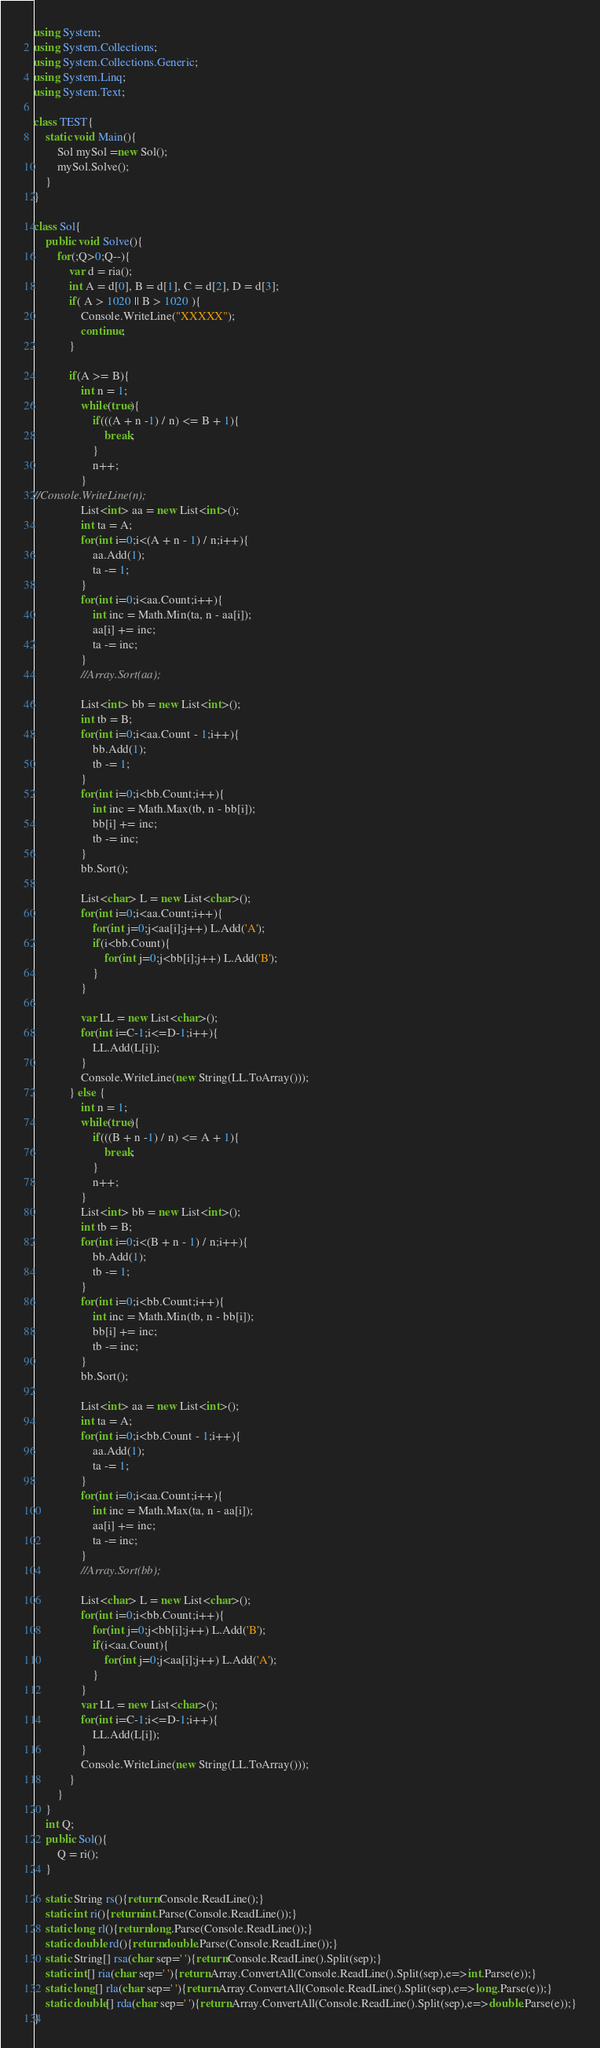<code> <loc_0><loc_0><loc_500><loc_500><_C#_>using System;
using System.Collections;
using System.Collections.Generic;
using System.Linq;
using System.Text;

class TEST{
	static void Main(){
		Sol mySol =new Sol();
		mySol.Solve();
	}
}

class Sol{
	public void Solve(){
		for(;Q>0;Q--){
			var d = ria();
			int A = d[0], B = d[1], C = d[2], D = d[3];
			if( A > 1020 || B > 1020 ){
				Console.WriteLine("XXXXX");
				continue;
			}
			
			if(A >= B){
				int n = 1;
				while(true){
					if(((A + n -1) / n) <= B + 1){
						break;
					}
					n++;
				}
//Console.WriteLine(n);				
				List<int> aa = new List<int>();
				int ta = A;
				for(int i=0;i<(A + n - 1) / n;i++){
					aa.Add(1);
					ta -= 1;
				}
				for(int i=0;i<aa.Count;i++){
					int inc = Math.Min(ta, n - aa[i]);
					aa[i] += inc;
					ta -= inc;
				}
				//Array.Sort(aa);
				
				List<int> bb = new List<int>();
				int tb = B;
				for(int i=0;i<aa.Count - 1;i++){
					bb.Add(1);
					tb -= 1;
				}
				for(int i=0;i<bb.Count;i++){
					int inc = Math.Max(tb, n - bb[i]);
					bb[i] += inc;
					tb -= inc;
				}
				bb.Sort();
				
				List<char> L = new List<char>();
				for(int i=0;i<aa.Count;i++){
					for(int j=0;j<aa[i];j++) L.Add('A');
					if(i<bb.Count){
						for(int j=0;j<bb[i];j++) L.Add('B');
					}
				}
				
				var LL = new List<char>();
				for(int i=C-1;i<=D-1;i++){
					LL.Add(L[i]);
				}
				Console.WriteLine(new String(LL.ToArray()));
			} else {
				int n = 1;
				while(true){
					if(((B + n -1) / n) <= A + 1){
						break;
					}
					n++;
				}
				List<int> bb = new List<int>();
				int tb = B;
				for(int i=0;i<(B + n - 1) / n;i++){
					bb.Add(1);
					tb -= 1;
				}
				for(int i=0;i<bb.Count;i++){
					int inc = Math.Min(tb, n - bb[i]);
					bb[i] += inc;
					tb -= inc;
				}
				bb.Sort();
				
				List<int> aa = new List<int>();
				int ta = A;
				for(int i=0;i<bb.Count - 1;i++){
					aa.Add(1);
					ta -= 1;
				}
				for(int i=0;i<aa.Count;i++){
					int inc = Math.Max(ta, n - aa[i]);
					aa[i] += inc;
					ta -= inc;
				}
				//Array.Sort(bb);
				
				List<char> L = new List<char>();
				for(int i=0;i<bb.Count;i++){
					for(int j=0;j<bb[i];j++) L.Add('B');
					if(i<aa.Count){
						for(int j=0;j<aa[i];j++) L.Add('A');
					}
				}
				var LL = new List<char>();
				for(int i=C-1;i<=D-1;i++){
					LL.Add(L[i]);
				}
				Console.WriteLine(new String(LL.ToArray()));
			}
		}
	}
	int Q;
	public Sol(){
		Q = ri();
	}

	static String rs(){return Console.ReadLine();}
	static int ri(){return int.Parse(Console.ReadLine());}
	static long rl(){return long.Parse(Console.ReadLine());}
	static double rd(){return double.Parse(Console.ReadLine());}
	static String[] rsa(char sep=' '){return Console.ReadLine().Split(sep);}
	static int[] ria(char sep=' '){return Array.ConvertAll(Console.ReadLine().Split(sep),e=>int.Parse(e));}
	static long[] rla(char sep=' '){return Array.ConvertAll(Console.ReadLine().Split(sep),e=>long.Parse(e));}
	static double[] rda(char sep=' '){return Array.ConvertAll(Console.ReadLine().Split(sep),e=>double.Parse(e));}
}
</code> 